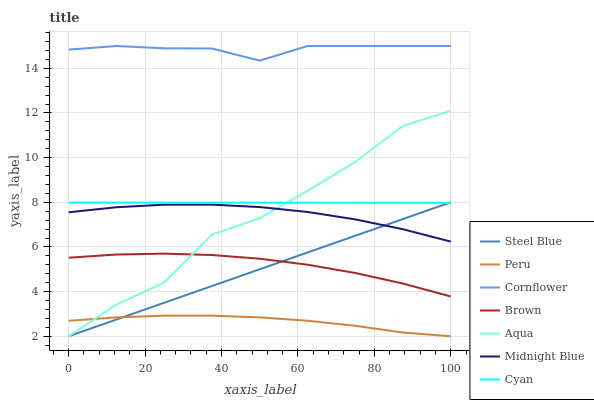Does Peru have the minimum area under the curve?
Answer yes or no. Yes. Does Cornflower have the maximum area under the curve?
Answer yes or no. Yes. Does Midnight Blue have the minimum area under the curve?
Answer yes or no. No. Does Midnight Blue have the maximum area under the curve?
Answer yes or no. No. Is Steel Blue the smoothest?
Answer yes or no. Yes. Is Aqua the roughest?
Answer yes or no. Yes. Is Midnight Blue the smoothest?
Answer yes or no. No. Is Midnight Blue the roughest?
Answer yes or no. No. Does Aqua have the lowest value?
Answer yes or no. Yes. Does Midnight Blue have the lowest value?
Answer yes or no. No. Does Cornflower have the highest value?
Answer yes or no. Yes. Does Midnight Blue have the highest value?
Answer yes or no. No. Is Midnight Blue less than Cyan?
Answer yes or no. Yes. Is Midnight Blue greater than Brown?
Answer yes or no. Yes. Does Aqua intersect Peru?
Answer yes or no. Yes. Is Aqua less than Peru?
Answer yes or no. No. Is Aqua greater than Peru?
Answer yes or no. No. Does Midnight Blue intersect Cyan?
Answer yes or no. No. 